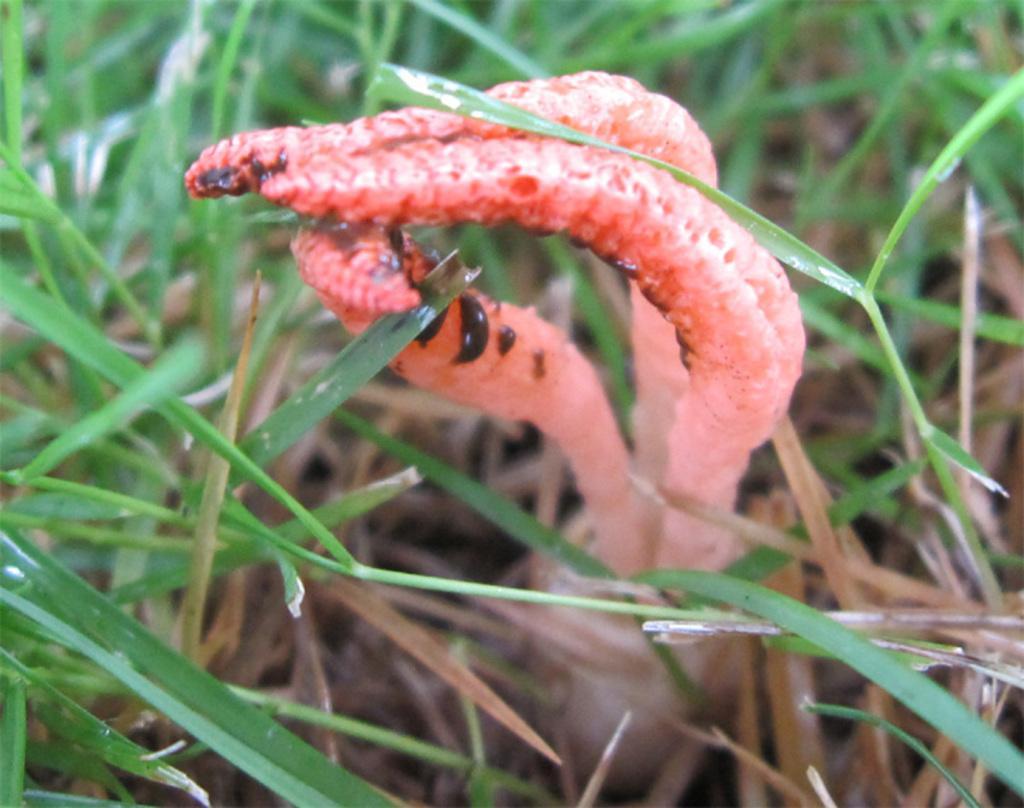Could you give a brief overview of what you see in this image? In the center of the image we can see a plant. In the background, we can see the grass. 